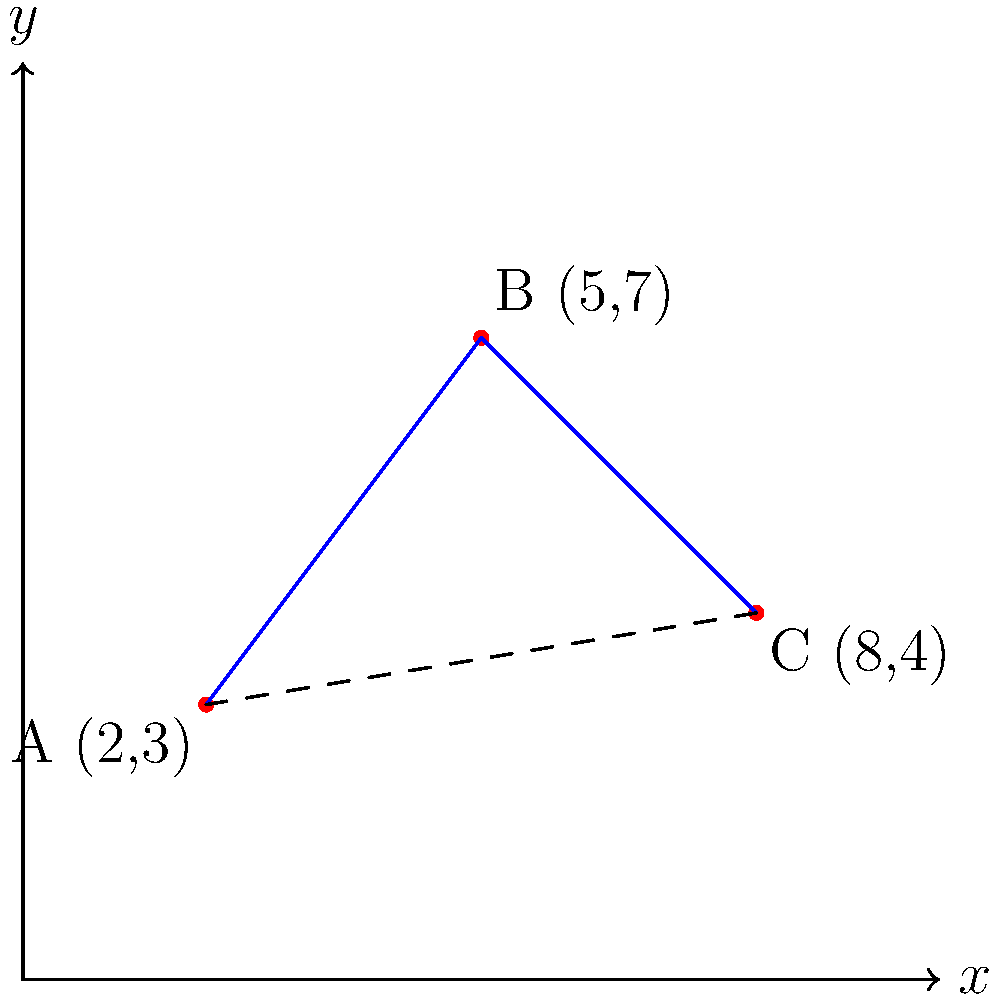A bike courier in a bustling city needs to deliver packages to three locations: A(2,3), B(5,7), and C(8,4). The courier starts at point A and must visit all locations before returning to the starting point. What is the shortest total distance the courier must travel, assuming they can move freely in straight lines between points? Round your answer to the nearest tenth of a unit. Let's approach this step-by-step:

1) We need to calculate the distances between each pair of points using the distance formula: $d = \sqrt{(x_2-x_1)^2 + (y_2-y_1)^2}$

2) Distance from A to B:
   $AB = \sqrt{(5-2)^2 + (7-3)^2} = \sqrt{3^2 + 4^2} = \sqrt{25} = 5$ units

3) Distance from B to C:
   $BC = \sqrt{(8-5)^2 + (4-7)^2} = \sqrt{3^2 + (-3)^2} = \sqrt{18} \approx 4.24$ units

4) Distance from C to A:
   $CA = \sqrt{(2-8)^2 + (3-4)^2} = \sqrt{(-6)^2 + (-1)^2} = \sqrt{37} \approx 6.08$ units

5) The courier has two possible routes:
   Route 1: A → B → C → A
   Route 2: A → C → B → A

6) Total distance for Route 1:
   $5 + 4.24 + 6.08 = 15.32$ units

7) Total distance for Route 2:
   $6.08 + 4.24 + 5 = 15.32$ units

8) Both routes have the same total distance, which is the shortest possible.

9) Rounding to the nearest tenth: 15.3 units
Answer: 15.3 units 